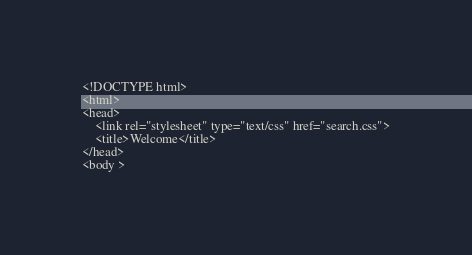Convert code to text. <code><loc_0><loc_0><loc_500><loc_500><_PHP_><!DOCTYPE html>
<html>
<head>
	<link rel="stylesheet" type="text/css" href="search.css">
	<title>Welcome</title>
</head>
<body >
</code> 